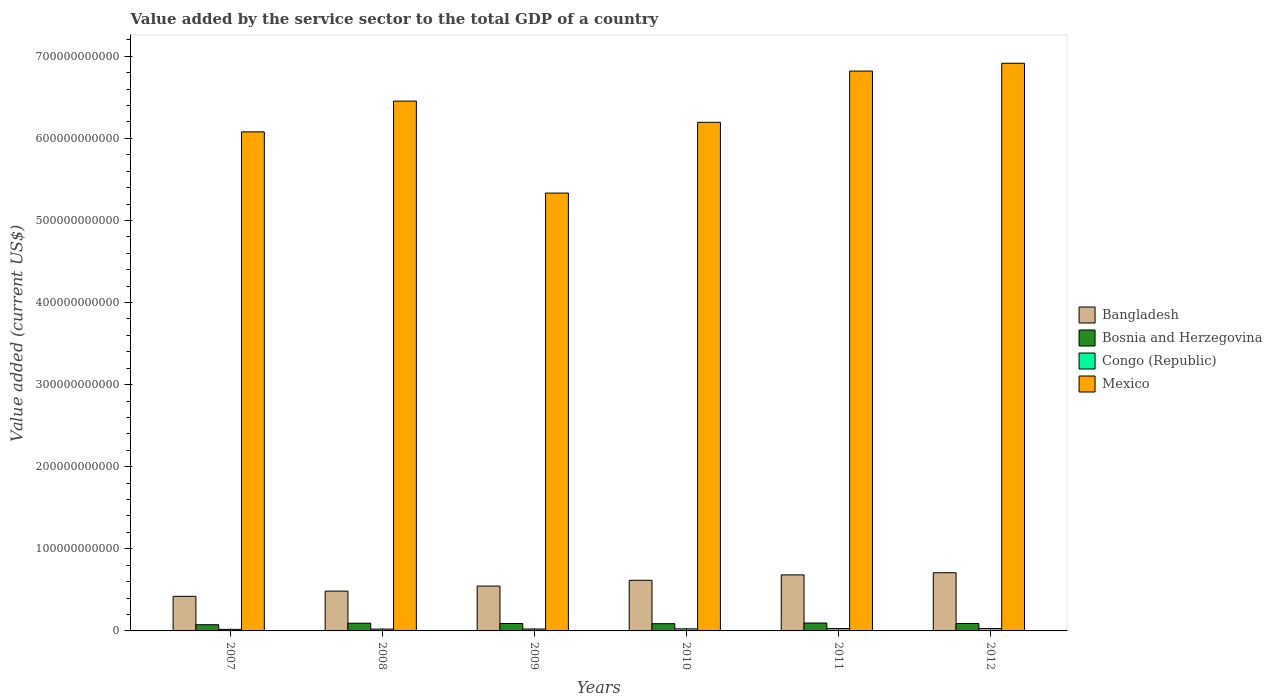How many different coloured bars are there?
Make the answer very short. 4. In how many cases, is the number of bars for a given year not equal to the number of legend labels?
Offer a very short reply. 0. What is the value added by the service sector to the total GDP in Bosnia and Herzegovina in 2012?
Make the answer very short. 9.06e+09. Across all years, what is the maximum value added by the service sector to the total GDP in Bosnia and Herzegovina?
Make the answer very short. 9.64e+09. Across all years, what is the minimum value added by the service sector to the total GDP in Bosnia and Herzegovina?
Give a very brief answer. 7.56e+09. In which year was the value added by the service sector to the total GDP in Bangladesh maximum?
Offer a very short reply. 2012. What is the total value added by the service sector to the total GDP in Bangladesh in the graph?
Your response must be concise. 3.46e+11. What is the difference between the value added by the service sector to the total GDP in Mexico in 2008 and that in 2011?
Keep it short and to the point. -3.66e+1. What is the difference between the value added by the service sector to the total GDP in Bosnia and Herzegovina in 2010 and the value added by the service sector to the total GDP in Mexico in 2009?
Give a very brief answer. -5.25e+11. What is the average value added by the service sector to the total GDP in Congo (Republic) per year?
Your response must be concise. 2.46e+09. In the year 2007, what is the difference between the value added by the service sector to the total GDP in Bosnia and Herzegovina and value added by the service sector to the total GDP in Bangladesh?
Provide a succinct answer. -3.45e+1. In how many years, is the value added by the service sector to the total GDP in Mexico greater than 160000000000 US$?
Offer a very short reply. 6. What is the ratio of the value added by the service sector to the total GDP in Bosnia and Herzegovina in 2010 to that in 2011?
Offer a terse response. 0.91. Is the value added by the service sector to the total GDP in Bangladesh in 2007 less than that in 2010?
Your answer should be very brief. Yes. Is the difference between the value added by the service sector to the total GDP in Bosnia and Herzegovina in 2007 and 2009 greater than the difference between the value added by the service sector to the total GDP in Bangladesh in 2007 and 2009?
Your answer should be compact. Yes. What is the difference between the highest and the second highest value added by the service sector to the total GDP in Bosnia and Herzegovina?
Offer a very short reply. 2.33e+08. What is the difference between the highest and the lowest value added by the service sector to the total GDP in Congo (Republic)?
Your answer should be very brief. 1.03e+09. In how many years, is the value added by the service sector to the total GDP in Bangladesh greater than the average value added by the service sector to the total GDP in Bangladesh taken over all years?
Offer a very short reply. 3. Is the sum of the value added by the service sector to the total GDP in Congo (Republic) in 2011 and 2012 greater than the maximum value added by the service sector to the total GDP in Bosnia and Herzegovina across all years?
Keep it short and to the point. No. What does the 3rd bar from the right in 2012 represents?
Make the answer very short. Bosnia and Herzegovina. Is it the case that in every year, the sum of the value added by the service sector to the total GDP in Congo (Republic) and value added by the service sector to the total GDP in Bangladesh is greater than the value added by the service sector to the total GDP in Bosnia and Herzegovina?
Make the answer very short. Yes. How many bars are there?
Make the answer very short. 24. What is the difference between two consecutive major ticks on the Y-axis?
Your response must be concise. 1.00e+11. Does the graph contain any zero values?
Ensure brevity in your answer.  No. How many legend labels are there?
Offer a terse response. 4. How are the legend labels stacked?
Ensure brevity in your answer.  Vertical. What is the title of the graph?
Your answer should be very brief. Value added by the service sector to the total GDP of a country. What is the label or title of the X-axis?
Offer a very short reply. Years. What is the label or title of the Y-axis?
Ensure brevity in your answer.  Value added (current US$). What is the Value added (current US$) of Bangladesh in 2007?
Offer a very short reply. 4.21e+1. What is the Value added (current US$) in Bosnia and Herzegovina in 2007?
Ensure brevity in your answer.  7.56e+09. What is the Value added (current US$) of Congo (Republic) in 2007?
Provide a succinct answer. 1.88e+09. What is the Value added (current US$) of Mexico in 2007?
Give a very brief answer. 6.08e+11. What is the Value added (current US$) in Bangladesh in 2008?
Give a very brief answer. 4.85e+1. What is the Value added (current US$) in Bosnia and Herzegovina in 2008?
Ensure brevity in your answer.  9.40e+09. What is the Value added (current US$) in Congo (Republic) in 2008?
Provide a succinct answer. 2.24e+09. What is the Value added (current US$) in Mexico in 2008?
Your answer should be compact. 6.45e+11. What is the Value added (current US$) of Bangladesh in 2009?
Offer a very short reply. 5.46e+1. What is the Value added (current US$) of Bosnia and Herzegovina in 2009?
Your answer should be very brief. 9.04e+09. What is the Value added (current US$) in Congo (Republic) in 2009?
Provide a short and direct response. 2.34e+09. What is the Value added (current US$) in Mexico in 2009?
Your answer should be compact. 5.33e+11. What is the Value added (current US$) in Bangladesh in 2010?
Your answer should be compact. 6.17e+1. What is the Value added (current US$) in Bosnia and Herzegovina in 2010?
Make the answer very short. 8.81e+09. What is the Value added (current US$) in Congo (Republic) in 2010?
Offer a very short reply. 2.50e+09. What is the Value added (current US$) of Mexico in 2010?
Your answer should be very brief. 6.20e+11. What is the Value added (current US$) of Bangladesh in 2011?
Offer a very short reply. 6.82e+1. What is the Value added (current US$) of Bosnia and Herzegovina in 2011?
Ensure brevity in your answer.  9.64e+09. What is the Value added (current US$) in Congo (Republic) in 2011?
Keep it short and to the point. 2.88e+09. What is the Value added (current US$) of Mexico in 2011?
Make the answer very short. 6.82e+11. What is the Value added (current US$) in Bangladesh in 2012?
Provide a succinct answer. 7.09e+1. What is the Value added (current US$) of Bosnia and Herzegovina in 2012?
Keep it short and to the point. 9.06e+09. What is the Value added (current US$) of Congo (Republic) in 2012?
Provide a short and direct response. 2.91e+09. What is the Value added (current US$) in Mexico in 2012?
Offer a terse response. 6.91e+11. Across all years, what is the maximum Value added (current US$) of Bangladesh?
Make the answer very short. 7.09e+1. Across all years, what is the maximum Value added (current US$) of Bosnia and Herzegovina?
Give a very brief answer. 9.64e+09. Across all years, what is the maximum Value added (current US$) of Congo (Republic)?
Ensure brevity in your answer.  2.91e+09. Across all years, what is the maximum Value added (current US$) of Mexico?
Your answer should be compact. 6.91e+11. Across all years, what is the minimum Value added (current US$) of Bangladesh?
Provide a short and direct response. 4.21e+1. Across all years, what is the minimum Value added (current US$) in Bosnia and Herzegovina?
Offer a terse response. 7.56e+09. Across all years, what is the minimum Value added (current US$) in Congo (Republic)?
Your response must be concise. 1.88e+09. Across all years, what is the minimum Value added (current US$) of Mexico?
Keep it short and to the point. 5.33e+11. What is the total Value added (current US$) in Bangladesh in the graph?
Your response must be concise. 3.46e+11. What is the total Value added (current US$) in Bosnia and Herzegovina in the graph?
Ensure brevity in your answer.  5.35e+1. What is the total Value added (current US$) of Congo (Republic) in the graph?
Ensure brevity in your answer.  1.48e+1. What is the total Value added (current US$) in Mexico in the graph?
Offer a terse response. 3.78e+12. What is the difference between the Value added (current US$) in Bangladesh in 2007 and that in 2008?
Provide a succinct answer. -6.40e+09. What is the difference between the Value added (current US$) in Bosnia and Herzegovina in 2007 and that in 2008?
Keep it short and to the point. -1.84e+09. What is the difference between the Value added (current US$) of Congo (Republic) in 2007 and that in 2008?
Provide a succinct answer. -3.59e+08. What is the difference between the Value added (current US$) in Mexico in 2007 and that in 2008?
Provide a succinct answer. -3.75e+1. What is the difference between the Value added (current US$) in Bangladesh in 2007 and that in 2009?
Provide a succinct answer. -1.25e+1. What is the difference between the Value added (current US$) of Bosnia and Herzegovina in 2007 and that in 2009?
Your response must be concise. -1.47e+09. What is the difference between the Value added (current US$) in Congo (Republic) in 2007 and that in 2009?
Your response must be concise. -4.56e+08. What is the difference between the Value added (current US$) of Mexico in 2007 and that in 2009?
Provide a short and direct response. 7.45e+1. What is the difference between the Value added (current US$) in Bangladesh in 2007 and that in 2010?
Provide a short and direct response. -1.96e+1. What is the difference between the Value added (current US$) in Bosnia and Herzegovina in 2007 and that in 2010?
Provide a succinct answer. -1.25e+09. What is the difference between the Value added (current US$) in Congo (Republic) in 2007 and that in 2010?
Your answer should be very brief. -6.14e+08. What is the difference between the Value added (current US$) in Mexico in 2007 and that in 2010?
Your response must be concise. -1.16e+1. What is the difference between the Value added (current US$) of Bangladesh in 2007 and that in 2011?
Keep it short and to the point. -2.61e+1. What is the difference between the Value added (current US$) in Bosnia and Herzegovina in 2007 and that in 2011?
Ensure brevity in your answer.  -2.07e+09. What is the difference between the Value added (current US$) of Congo (Republic) in 2007 and that in 2011?
Provide a succinct answer. -1.00e+09. What is the difference between the Value added (current US$) of Mexico in 2007 and that in 2011?
Make the answer very short. -7.41e+1. What is the difference between the Value added (current US$) of Bangladesh in 2007 and that in 2012?
Ensure brevity in your answer.  -2.88e+1. What is the difference between the Value added (current US$) in Bosnia and Herzegovina in 2007 and that in 2012?
Give a very brief answer. -1.49e+09. What is the difference between the Value added (current US$) in Congo (Republic) in 2007 and that in 2012?
Your answer should be compact. -1.03e+09. What is the difference between the Value added (current US$) in Mexico in 2007 and that in 2012?
Provide a succinct answer. -8.36e+1. What is the difference between the Value added (current US$) in Bangladesh in 2008 and that in 2009?
Your response must be concise. -6.14e+09. What is the difference between the Value added (current US$) in Bosnia and Herzegovina in 2008 and that in 2009?
Offer a very short reply. 3.69e+08. What is the difference between the Value added (current US$) in Congo (Republic) in 2008 and that in 2009?
Provide a succinct answer. -9.62e+07. What is the difference between the Value added (current US$) of Mexico in 2008 and that in 2009?
Make the answer very short. 1.12e+11. What is the difference between the Value added (current US$) in Bangladesh in 2008 and that in 2010?
Your answer should be compact. -1.32e+1. What is the difference between the Value added (current US$) in Bosnia and Herzegovina in 2008 and that in 2010?
Make the answer very short. 5.95e+08. What is the difference between the Value added (current US$) in Congo (Republic) in 2008 and that in 2010?
Provide a succinct answer. -2.54e+08. What is the difference between the Value added (current US$) in Mexico in 2008 and that in 2010?
Offer a terse response. 2.59e+1. What is the difference between the Value added (current US$) in Bangladesh in 2008 and that in 2011?
Your response must be concise. -1.97e+1. What is the difference between the Value added (current US$) of Bosnia and Herzegovina in 2008 and that in 2011?
Your response must be concise. -2.33e+08. What is the difference between the Value added (current US$) in Congo (Republic) in 2008 and that in 2011?
Give a very brief answer. -6.41e+08. What is the difference between the Value added (current US$) of Mexico in 2008 and that in 2011?
Make the answer very short. -3.66e+1. What is the difference between the Value added (current US$) in Bangladesh in 2008 and that in 2012?
Offer a terse response. -2.24e+1. What is the difference between the Value added (current US$) in Bosnia and Herzegovina in 2008 and that in 2012?
Your answer should be compact. 3.47e+08. What is the difference between the Value added (current US$) of Congo (Republic) in 2008 and that in 2012?
Ensure brevity in your answer.  -6.72e+08. What is the difference between the Value added (current US$) of Mexico in 2008 and that in 2012?
Your answer should be compact. -4.61e+1. What is the difference between the Value added (current US$) of Bangladesh in 2009 and that in 2010?
Your answer should be compact. -7.03e+09. What is the difference between the Value added (current US$) in Bosnia and Herzegovina in 2009 and that in 2010?
Offer a terse response. 2.26e+08. What is the difference between the Value added (current US$) of Congo (Republic) in 2009 and that in 2010?
Make the answer very short. -1.58e+08. What is the difference between the Value added (current US$) of Mexico in 2009 and that in 2010?
Provide a succinct answer. -8.62e+1. What is the difference between the Value added (current US$) of Bangladesh in 2009 and that in 2011?
Keep it short and to the point. -1.36e+1. What is the difference between the Value added (current US$) of Bosnia and Herzegovina in 2009 and that in 2011?
Give a very brief answer. -6.02e+08. What is the difference between the Value added (current US$) of Congo (Republic) in 2009 and that in 2011?
Provide a succinct answer. -5.45e+08. What is the difference between the Value added (current US$) in Mexico in 2009 and that in 2011?
Make the answer very short. -1.49e+11. What is the difference between the Value added (current US$) in Bangladesh in 2009 and that in 2012?
Provide a succinct answer. -1.62e+1. What is the difference between the Value added (current US$) of Bosnia and Herzegovina in 2009 and that in 2012?
Provide a succinct answer. -2.16e+07. What is the difference between the Value added (current US$) of Congo (Republic) in 2009 and that in 2012?
Provide a succinct answer. -5.76e+08. What is the difference between the Value added (current US$) in Mexico in 2009 and that in 2012?
Make the answer very short. -1.58e+11. What is the difference between the Value added (current US$) in Bangladesh in 2010 and that in 2011?
Provide a short and direct response. -6.56e+09. What is the difference between the Value added (current US$) of Bosnia and Herzegovina in 2010 and that in 2011?
Your answer should be compact. -8.27e+08. What is the difference between the Value added (current US$) in Congo (Republic) in 2010 and that in 2011?
Ensure brevity in your answer.  -3.87e+08. What is the difference between the Value added (current US$) in Mexico in 2010 and that in 2011?
Your response must be concise. -6.24e+1. What is the difference between the Value added (current US$) of Bangladesh in 2010 and that in 2012?
Provide a short and direct response. -9.21e+09. What is the difference between the Value added (current US$) in Bosnia and Herzegovina in 2010 and that in 2012?
Keep it short and to the point. -2.48e+08. What is the difference between the Value added (current US$) of Congo (Republic) in 2010 and that in 2012?
Ensure brevity in your answer.  -4.18e+08. What is the difference between the Value added (current US$) of Mexico in 2010 and that in 2012?
Offer a terse response. -7.19e+1. What is the difference between the Value added (current US$) of Bangladesh in 2011 and that in 2012?
Offer a very short reply. -2.64e+09. What is the difference between the Value added (current US$) in Bosnia and Herzegovina in 2011 and that in 2012?
Give a very brief answer. 5.80e+08. What is the difference between the Value added (current US$) of Congo (Republic) in 2011 and that in 2012?
Your response must be concise. -3.04e+07. What is the difference between the Value added (current US$) in Mexico in 2011 and that in 2012?
Keep it short and to the point. -9.51e+09. What is the difference between the Value added (current US$) of Bangladesh in 2007 and the Value added (current US$) of Bosnia and Herzegovina in 2008?
Your response must be concise. 3.27e+1. What is the difference between the Value added (current US$) of Bangladesh in 2007 and the Value added (current US$) of Congo (Republic) in 2008?
Offer a terse response. 3.99e+1. What is the difference between the Value added (current US$) in Bangladesh in 2007 and the Value added (current US$) in Mexico in 2008?
Make the answer very short. -6.03e+11. What is the difference between the Value added (current US$) of Bosnia and Herzegovina in 2007 and the Value added (current US$) of Congo (Republic) in 2008?
Ensure brevity in your answer.  5.32e+09. What is the difference between the Value added (current US$) in Bosnia and Herzegovina in 2007 and the Value added (current US$) in Mexico in 2008?
Provide a short and direct response. -6.38e+11. What is the difference between the Value added (current US$) of Congo (Republic) in 2007 and the Value added (current US$) of Mexico in 2008?
Provide a succinct answer. -6.44e+11. What is the difference between the Value added (current US$) of Bangladesh in 2007 and the Value added (current US$) of Bosnia and Herzegovina in 2009?
Provide a short and direct response. 3.31e+1. What is the difference between the Value added (current US$) of Bangladesh in 2007 and the Value added (current US$) of Congo (Republic) in 2009?
Your answer should be compact. 3.98e+1. What is the difference between the Value added (current US$) in Bangladesh in 2007 and the Value added (current US$) in Mexico in 2009?
Give a very brief answer. -4.91e+11. What is the difference between the Value added (current US$) of Bosnia and Herzegovina in 2007 and the Value added (current US$) of Congo (Republic) in 2009?
Offer a very short reply. 5.22e+09. What is the difference between the Value added (current US$) of Bosnia and Herzegovina in 2007 and the Value added (current US$) of Mexico in 2009?
Make the answer very short. -5.26e+11. What is the difference between the Value added (current US$) of Congo (Republic) in 2007 and the Value added (current US$) of Mexico in 2009?
Provide a short and direct response. -5.31e+11. What is the difference between the Value added (current US$) in Bangladesh in 2007 and the Value added (current US$) in Bosnia and Herzegovina in 2010?
Ensure brevity in your answer.  3.33e+1. What is the difference between the Value added (current US$) in Bangladesh in 2007 and the Value added (current US$) in Congo (Republic) in 2010?
Provide a short and direct response. 3.96e+1. What is the difference between the Value added (current US$) in Bangladesh in 2007 and the Value added (current US$) in Mexico in 2010?
Your response must be concise. -5.77e+11. What is the difference between the Value added (current US$) of Bosnia and Herzegovina in 2007 and the Value added (current US$) of Congo (Republic) in 2010?
Your answer should be very brief. 5.07e+09. What is the difference between the Value added (current US$) of Bosnia and Herzegovina in 2007 and the Value added (current US$) of Mexico in 2010?
Your answer should be compact. -6.12e+11. What is the difference between the Value added (current US$) of Congo (Republic) in 2007 and the Value added (current US$) of Mexico in 2010?
Make the answer very short. -6.18e+11. What is the difference between the Value added (current US$) of Bangladesh in 2007 and the Value added (current US$) of Bosnia and Herzegovina in 2011?
Your answer should be very brief. 3.25e+1. What is the difference between the Value added (current US$) of Bangladesh in 2007 and the Value added (current US$) of Congo (Republic) in 2011?
Your response must be concise. 3.92e+1. What is the difference between the Value added (current US$) in Bangladesh in 2007 and the Value added (current US$) in Mexico in 2011?
Keep it short and to the point. -6.40e+11. What is the difference between the Value added (current US$) in Bosnia and Herzegovina in 2007 and the Value added (current US$) in Congo (Republic) in 2011?
Provide a succinct answer. 4.68e+09. What is the difference between the Value added (current US$) of Bosnia and Herzegovina in 2007 and the Value added (current US$) of Mexico in 2011?
Give a very brief answer. -6.74e+11. What is the difference between the Value added (current US$) of Congo (Republic) in 2007 and the Value added (current US$) of Mexico in 2011?
Your answer should be very brief. -6.80e+11. What is the difference between the Value added (current US$) in Bangladesh in 2007 and the Value added (current US$) in Bosnia and Herzegovina in 2012?
Ensure brevity in your answer.  3.30e+1. What is the difference between the Value added (current US$) in Bangladesh in 2007 and the Value added (current US$) in Congo (Republic) in 2012?
Your answer should be compact. 3.92e+1. What is the difference between the Value added (current US$) of Bangladesh in 2007 and the Value added (current US$) of Mexico in 2012?
Offer a terse response. -6.49e+11. What is the difference between the Value added (current US$) of Bosnia and Herzegovina in 2007 and the Value added (current US$) of Congo (Republic) in 2012?
Your answer should be compact. 4.65e+09. What is the difference between the Value added (current US$) in Bosnia and Herzegovina in 2007 and the Value added (current US$) in Mexico in 2012?
Ensure brevity in your answer.  -6.84e+11. What is the difference between the Value added (current US$) in Congo (Republic) in 2007 and the Value added (current US$) in Mexico in 2012?
Your response must be concise. -6.90e+11. What is the difference between the Value added (current US$) in Bangladesh in 2008 and the Value added (current US$) in Bosnia and Herzegovina in 2009?
Keep it short and to the point. 3.95e+1. What is the difference between the Value added (current US$) in Bangladesh in 2008 and the Value added (current US$) in Congo (Republic) in 2009?
Your response must be concise. 4.62e+1. What is the difference between the Value added (current US$) in Bangladesh in 2008 and the Value added (current US$) in Mexico in 2009?
Your response must be concise. -4.85e+11. What is the difference between the Value added (current US$) in Bosnia and Herzegovina in 2008 and the Value added (current US$) in Congo (Republic) in 2009?
Ensure brevity in your answer.  7.07e+09. What is the difference between the Value added (current US$) of Bosnia and Herzegovina in 2008 and the Value added (current US$) of Mexico in 2009?
Offer a very short reply. -5.24e+11. What is the difference between the Value added (current US$) in Congo (Republic) in 2008 and the Value added (current US$) in Mexico in 2009?
Offer a terse response. -5.31e+11. What is the difference between the Value added (current US$) of Bangladesh in 2008 and the Value added (current US$) of Bosnia and Herzegovina in 2010?
Provide a short and direct response. 3.97e+1. What is the difference between the Value added (current US$) of Bangladesh in 2008 and the Value added (current US$) of Congo (Republic) in 2010?
Ensure brevity in your answer.  4.60e+1. What is the difference between the Value added (current US$) of Bangladesh in 2008 and the Value added (current US$) of Mexico in 2010?
Ensure brevity in your answer.  -5.71e+11. What is the difference between the Value added (current US$) in Bosnia and Herzegovina in 2008 and the Value added (current US$) in Congo (Republic) in 2010?
Ensure brevity in your answer.  6.91e+09. What is the difference between the Value added (current US$) in Bosnia and Herzegovina in 2008 and the Value added (current US$) in Mexico in 2010?
Your answer should be compact. -6.10e+11. What is the difference between the Value added (current US$) of Congo (Republic) in 2008 and the Value added (current US$) of Mexico in 2010?
Keep it short and to the point. -6.17e+11. What is the difference between the Value added (current US$) of Bangladesh in 2008 and the Value added (current US$) of Bosnia and Herzegovina in 2011?
Your response must be concise. 3.89e+1. What is the difference between the Value added (current US$) in Bangladesh in 2008 and the Value added (current US$) in Congo (Republic) in 2011?
Offer a terse response. 4.56e+1. What is the difference between the Value added (current US$) in Bangladesh in 2008 and the Value added (current US$) in Mexico in 2011?
Keep it short and to the point. -6.33e+11. What is the difference between the Value added (current US$) in Bosnia and Herzegovina in 2008 and the Value added (current US$) in Congo (Republic) in 2011?
Your answer should be very brief. 6.52e+09. What is the difference between the Value added (current US$) of Bosnia and Herzegovina in 2008 and the Value added (current US$) of Mexico in 2011?
Offer a terse response. -6.73e+11. What is the difference between the Value added (current US$) of Congo (Republic) in 2008 and the Value added (current US$) of Mexico in 2011?
Your answer should be very brief. -6.80e+11. What is the difference between the Value added (current US$) in Bangladesh in 2008 and the Value added (current US$) in Bosnia and Herzegovina in 2012?
Offer a terse response. 3.94e+1. What is the difference between the Value added (current US$) in Bangladesh in 2008 and the Value added (current US$) in Congo (Republic) in 2012?
Your answer should be very brief. 4.56e+1. What is the difference between the Value added (current US$) in Bangladesh in 2008 and the Value added (current US$) in Mexico in 2012?
Offer a very short reply. -6.43e+11. What is the difference between the Value added (current US$) of Bosnia and Herzegovina in 2008 and the Value added (current US$) of Congo (Republic) in 2012?
Your answer should be very brief. 6.49e+09. What is the difference between the Value added (current US$) in Bosnia and Herzegovina in 2008 and the Value added (current US$) in Mexico in 2012?
Offer a terse response. -6.82e+11. What is the difference between the Value added (current US$) of Congo (Republic) in 2008 and the Value added (current US$) of Mexico in 2012?
Offer a very short reply. -6.89e+11. What is the difference between the Value added (current US$) in Bangladesh in 2009 and the Value added (current US$) in Bosnia and Herzegovina in 2010?
Provide a succinct answer. 4.58e+1. What is the difference between the Value added (current US$) in Bangladesh in 2009 and the Value added (current US$) in Congo (Republic) in 2010?
Make the answer very short. 5.21e+1. What is the difference between the Value added (current US$) in Bangladesh in 2009 and the Value added (current US$) in Mexico in 2010?
Your response must be concise. -5.65e+11. What is the difference between the Value added (current US$) in Bosnia and Herzegovina in 2009 and the Value added (current US$) in Congo (Republic) in 2010?
Give a very brief answer. 6.54e+09. What is the difference between the Value added (current US$) in Bosnia and Herzegovina in 2009 and the Value added (current US$) in Mexico in 2010?
Provide a short and direct response. -6.10e+11. What is the difference between the Value added (current US$) in Congo (Republic) in 2009 and the Value added (current US$) in Mexico in 2010?
Your response must be concise. -6.17e+11. What is the difference between the Value added (current US$) in Bangladesh in 2009 and the Value added (current US$) in Bosnia and Herzegovina in 2011?
Your answer should be compact. 4.50e+1. What is the difference between the Value added (current US$) in Bangladesh in 2009 and the Value added (current US$) in Congo (Republic) in 2011?
Keep it short and to the point. 5.18e+1. What is the difference between the Value added (current US$) of Bangladesh in 2009 and the Value added (current US$) of Mexico in 2011?
Ensure brevity in your answer.  -6.27e+11. What is the difference between the Value added (current US$) of Bosnia and Herzegovina in 2009 and the Value added (current US$) of Congo (Republic) in 2011?
Keep it short and to the point. 6.15e+09. What is the difference between the Value added (current US$) in Bosnia and Herzegovina in 2009 and the Value added (current US$) in Mexico in 2011?
Keep it short and to the point. -6.73e+11. What is the difference between the Value added (current US$) of Congo (Republic) in 2009 and the Value added (current US$) of Mexico in 2011?
Ensure brevity in your answer.  -6.80e+11. What is the difference between the Value added (current US$) in Bangladesh in 2009 and the Value added (current US$) in Bosnia and Herzegovina in 2012?
Your answer should be very brief. 4.56e+1. What is the difference between the Value added (current US$) in Bangladesh in 2009 and the Value added (current US$) in Congo (Republic) in 2012?
Your answer should be very brief. 5.17e+1. What is the difference between the Value added (current US$) of Bangladesh in 2009 and the Value added (current US$) of Mexico in 2012?
Keep it short and to the point. -6.37e+11. What is the difference between the Value added (current US$) of Bosnia and Herzegovina in 2009 and the Value added (current US$) of Congo (Republic) in 2012?
Make the answer very short. 6.12e+09. What is the difference between the Value added (current US$) in Bosnia and Herzegovina in 2009 and the Value added (current US$) in Mexico in 2012?
Ensure brevity in your answer.  -6.82e+11. What is the difference between the Value added (current US$) of Congo (Republic) in 2009 and the Value added (current US$) of Mexico in 2012?
Give a very brief answer. -6.89e+11. What is the difference between the Value added (current US$) in Bangladesh in 2010 and the Value added (current US$) in Bosnia and Herzegovina in 2011?
Offer a terse response. 5.20e+1. What is the difference between the Value added (current US$) in Bangladesh in 2010 and the Value added (current US$) in Congo (Republic) in 2011?
Give a very brief answer. 5.88e+1. What is the difference between the Value added (current US$) of Bangladesh in 2010 and the Value added (current US$) of Mexico in 2011?
Give a very brief answer. -6.20e+11. What is the difference between the Value added (current US$) of Bosnia and Herzegovina in 2010 and the Value added (current US$) of Congo (Republic) in 2011?
Your response must be concise. 5.93e+09. What is the difference between the Value added (current US$) in Bosnia and Herzegovina in 2010 and the Value added (current US$) in Mexico in 2011?
Give a very brief answer. -6.73e+11. What is the difference between the Value added (current US$) of Congo (Republic) in 2010 and the Value added (current US$) of Mexico in 2011?
Ensure brevity in your answer.  -6.79e+11. What is the difference between the Value added (current US$) in Bangladesh in 2010 and the Value added (current US$) in Bosnia and Herzegovina in 2012?
Keep it short and to the point. 5.26e+1. What is the difference between the Value added (current US$) of Bangladesh in 2010 and the Value added (current US$) of Congo (Republic) in 2012?
Offer a terse response. 5.88e+1. What is the difference between the Value added (current US$) of Bangladesh in 2010 and the Value added (current US$) of Mexico in 2012?
Offer a terse response. -6.30e+11. What is the difference between the Value added (current US$) in Bosnia and Herzegovina in 2010 and the Value added (current US$) in Congo (Republic) in 2012?
Your answer should be very brief. 5.89e+09. What is the difference between the Value added (current US$) of Bosnia and Herzegovina in 2010 and the Value added (current US$) of Mexico in 2012?
Your answer should be very brief. -6.83e+11. What is the difference between the Value added (current US$) of Congo (Republic) in 2010 and the Value added (current US$) of Mexico in 2012?
Keep it short and to the point. -6.89e+11. What is the difference between the Value added (current US$) in Bangladesh in 2011 and the Value added (current US$) in Bosnia and Herzegovina in 2012?
Keep it short and to the point. 5.92e+1. What is the difference between the Value added (current US$) of Bangladesh in 2011 and the Value added (current US$) of Congo (Republic) in 2012?
Make the answer very short. 6.53e+1. What is the difference between the Value added (current US$) of Bangladesh in 2011 and the Value added (current US$) of Mexico in 2012?
Ensure brevity in your answer.  -6.23e+11. What is the difference between the Value added (current US$) of Bosnia and Herzegovina in 2011 and the Value added (current US$) of Congo (Republic) in 2012?
Ensure brevity in your answer.  6.72e+09. What is the difference between the Value added (current US$) in Bosnia and Herzegovina in 2011 and the Value added (current US$) in Mexico in 2012?
Offer a very short reply. -6.82e+11. What is the difference between the Value added (current US$) of Congo (Republic) in 2011 and the Value added (current US$) of Mexico in 2012?
Offer a terse response. -6.89e+11. What is the average Value added (current US$) in Bangladesh per year?
Your response must be concise. 5.77e+1. What is the average Value added (current US$) of Bosnia and Herzegovina per year?
Your answer should be very brief. 8.92e+09. What is the average Value added (current US$) of Congo (Republic) per year?
Ensure brevity in your answer.  2.46e+09. What is the average Value added (current US$) in Mexico per year?
Provide a short and direct response. 6.30e+11. In the year 2007, what is the difference between the Value added (current US$) of Bangladesh and Value added (current US$) of Bosnia and Herzegovina?
Offer a very short reply. 3.45e+1. In the year 2007, what is the difference between the Value added (current US$) in Bangladesh and Value added (current US$) in Congo (Republic)?
Give a very brief answer. 4.02e+1. In the year 2007, what is the difference between the Value added (current US$) of Bangladesh and Value added (current US$) of Mexico?
Provide a short and direct response. -5.66e+11. In the year 2007, what is the difference between the Value added (current US$) of Bosnia and Herzegovina and Value added (current US$) of Congo (Republic)?
Keep it short and to the point. 5.68e+09. In the year 2007, what is the difference between the Value added (current US$) of Bosnia and Herzegovina and Value added (current US$) of Mexico?
Offer a terse response. -6.00e+11. In the year 2007, what is the difference between the Value added (current US$) in Congo (Republic) and Value added (current US$) in Mexico?
Make the answer very short. -6.06e+11. In the year 2008, what is the difference between the Value added (current US$) of Bangladesh and Value added (current US$) of Bosnia and Herzegovina?
Make the answer very short. 3.91e+1. In the year 2008, what is the difference between the Value added (current US$) of Bangladesh and Value added (current US$) of Congo (Republic)?
Your answer should be very brief. 4.63e+1. In the year 2008, what is the difference between the Value added (current US$) in Bangladesh and Value added (current US$) in Mexico?
Offer a very short reply. -5.97e+11. In the year 2008, what is the difference between the Value added (current US$) in Bosnia and Herzegovina and Value added (current US$) in Congo (Republic)?
Give a very brief answer. 7.16e+09. In the year 2008, what is the difference between the Value added (current US$) of Bosnia and Herzegovina and Value added (current US$) of Mexico?
Your response must be concise. -6.36e+11. In the year 2008, what is the difference between the Value added (current US$) of Congo (Republic) and Value added (current US$) of Mexico?
Make the answer very short. -6.43e+11. In the year 2009, what is the difference between the Value added (current US$) of Bangladesh and Value added (current US$) of Bosnia and Herzegovina?
Provide a short and direct response. 4.56e+1. In the year 2009, what is the difference between the Value added (current US$) in Bangladesh and Value added (current US$) in Congo (Republic)?
Keep it short and to the point. 5.23e+1. In the year 2009, what is the difference between the Value added (current US$) in Bangladesh and Value added (current US$) in Mexico?
Offer a very short reply. -4.79e+11. In the year 2009, what is the difference between the Value added (current US$) in Bosnia and Herzegovina and Value added (current US$) in Congo (Republic)?
Give a very brief answer. 6.70e+09. In the year 2009, what is the difference between the Value added (current US$) of Bosnia and Herzegovina and Value added (current US$) of Mexico?
Offer a very short reply. -5.24e+11. In the year 2009, what is the difference between the Value added (current US$) in Congo (Republic) and Value added (current US$) in Mexico?
Provide a short and direct response. -5.31e+11. In the year 2010, what is the difference between the Value added (current US$) in Bangladesh and Value added (current US$) in Bosnia and Herzegovina?
Your response must be concise. 5.29e+1. In the year 2010, what is the difference between the Value added (current US$) of Bangladesh and Value added (current US$) of Congo (Republic)?
Offer a terse response. 5.92e+1. In the year 2010, what is the difference between the Value added (current US$) in Bangladesh and Value added (current US$) in Mexico?
Provide a succinct answer. -5.58e+11. In the year 2010, what is the difference between the Value added (current US$) in Bosnia and Herzegovina and Value added (current US$) in Congo (Republic)?
Provide a short and direct response. 6.31e+09. In the year 2010, what is the difference between the Value added (current US$) of Bosnia and Herzegovina and Value added (current US$) of Mexico?
Give a very brief answer. -6.11e+11. In the year 2010, what is the difference between the Value added (current US$) in Congo (Republic) and Value added (current US$) in Mexico?
Give a very brief answer. -6.17e+11. In the year 2011, what is the difference between the Value added (current US$) in Bangladesh and Value added (current US$) in Bosnia and Herzegovina?
Your answer should be very brief. 5.86e+1. In the year 2011, what is the difference between the Value added (current US$) in Bangladesh and Value added (current US$) in Congo (Republic)?
Your response must be concise. 6.54e+1. In the year 2011, what is the difference between the Value added (current US$) in Bangladesh and Value added (current US$) in Mexico?
Offer a terse response. -6.14e+11. In the year 2011, what is the difference between the Value added (current US$) in Bosnia and Herzegovina and Value added (current US$) in Congo (Republic)?
Make the answer very short. 6.75e+09. In the year 2011, what is the difference between the Value added (current US$) in Bosnia and Herzegovina and Value added (current US$) in Mexico?
Ensure brevity in your answer.  -6.72e+11. In the year 2011, what is the difference between the Value added (current US$) of Congo (Republic) and Value added (current US$) of Mexico?
Provide a succinct answer. -6.79e+11. In the year 2012, what is the difference between the Value added (current US$) of Bangladesh and Value added (current US$) of Bosnia and Herzegovina?
Provide a succinct answer. 6.18e+1. In the year 2012, what is the difference between the Value added (current US$) in Bangladesh and Value added (current US$) in Congo (Republic)?
Offer a terse response. 6.80e+1. In the year 2012, what is the difference between the Value added (current US$) in Bangladesh and Value added (current US$) in Mexico?
Offer a terse response. -6.21e+11. In the year 2012, what is the difference between the Value added (current US$) in Bosnia and Herzegovina and Value added (current US$) in Congo (Republic)?
Offer a terse response. 6.14e+09. In the year 2012, what is the difference between the Value added (current US$) in Bosnia and Herzegovina and Value added (current US$) in Mexico?
Give a very brief answer. -6.82e+11. In the year 2012, what is the difference between the Value added (current US$) in Congo (Republic) and Value added (current US$) in Mexico?
Provide a short and direct response. -6.89e+11. What is the ratio of the Value added (current US$) in Bangladesh in 2007 to that in 2008?
Offer a very short reply. 0.87. What is the ratio of the Value added (current US$) of Bosnia and Herzegovina in 2007 to that in 2008?
Offer a terse response. 0.8. What is the ratio of the Value added (current US$) in Congo (Republic) in 2007 to that in 2008?
Your answer should be very brief. 0.84. What is the ratio of the Value added (current US$) in Mexico in 2007 to that in 2008?
Your answer should be very brief. 0.94. What is the ratio of the Value added (current US$) of Bangladesh in 2007 to that in 2009?
Make the answer very short. 0.77. What is the ratio of the Value added (current US$) in Bosnia and Herzegovina in 2007 to that in 2009?
Provide a succinct answer. 0.84. What is the ratio of the Value added (current US$) of Congo (Republic) in 2007 to that in 2009?
Give a very brief answer. 0.81. What is the ratio of the Value added (current US$) of Mexico in 2007 to that in 2009?
Give a very brief answer. 1.14. What is the ratio of the Value added (current US$) of Bangladesh in 2007 to that in 2010?
Your response must be concise. 0.68. What is the ratio of the Value added (current US$) in Bosnia and Herzegovina in 2007 to that in 2010?
Offer a very short reply. 0.86. What is the ratio of the Value added (current US$) of Congo (Republic) in 2007 to that in 2010?
Give a very brief answer. 0.75. What is the ratio of the Value added (current US$) of Mexico in 2007 to that in 2010?
Your answer should be very brief. 0.98. What is the ratio of the Value added (current US$) of Bangladesh in 2007 to that in 2011?
Offer a very short reply. 0.62. What is the ratio of the Value added (current US$) of Bosnia and Herzegovina in 2007 to that in 2011?
Give a very brief answer. 0.78. What is the ratio of the Value added (current US$) of Congo (Republic) in 2007 to that in 2011?
Give a very brief answer. 0.65. What is the ratio of the Value added (current US$) of Mexico in 2007 to that in 2011?
Provide a short and direct response. 0.89. What is the ratio of the Value added (current US$) in Bangladesh in 2007 to that in 2012?
Provide a succinct answer. 0.59. What is the ratio of the Value added (current US$) in Bosnia and Herzegovina in 2007 to that in 2012?
Keep it short and to the point. 0.83. What is the ratio of the Value added (current US$) of Congo (Republic) in 2007 to that in 2012?
Your answer should be compact. 0.65. What is the ratio of the Value added (current US$) in Mexico in 2007 to that in 2012?
Keep it short and to the point. 0.88. What is the ratio of the Value added (current US$) in Bangladesh in 2008 to that in 2009?
Your answer should be compact. 0.89. What is the ratio of the Value added (current US$) of Bosnia and Herzegovina in 2008 to that in 2009?
Provide a short and direct response. 1.04. What is the ratio of the Value added (current US$) in Congo (Republic) in 2008 to that in 2009?
Keep it short and to the point. 0.96. What is the ratio of the Value added (current US$) in Mexico in 2008 to that in 2009?
Keep it short and to the point. 1.21. What is the ratio of the Value added (current US$) of Bangladesh in 2008 to that in 2010?
Offer a terse response. 0.79. What is the ratio of the Value added (current US$) of Bosnia and Herzegovina in 2008 to that in 2010?
Give a very brief answer. 1.07. What is the ratio of the Value added (current US$) in Congo (Republic) in 2008 to that in 2010?
Offer a terse response. 0.9. What is the ratio of the Value added (current US$) in Mexico in 2008 to that in 2010?
Offer a terse response. 1.04. What is the ratio of the Value added (current US$) of Bangladesh in 2008 to that in 2011?
Ensure brevity in your answer.  0.71. What is the ratio of the Value added (current US$) of Bosnia and Herzegovina in 2008 to that in 2011?
Ensure brevity in your answer.  0.98. What is the ratio of the Value added (current US$) in Congo (Republic) in 2008 to that in 2011?
Provide a succinct answer. 0.78. What is the ratio of the Value added (current US$) in Mexico in 2008 to that in 2011?
Your answer should be compact. 0.95. What is the ratio of the Value added (current US$) in Bangladesh in 2008 to that in 2012?
Your answer should be compact. 0.68. What is the ratio of the Value added (current US$) of Bosnia and Herzegovina in 2008 to that in 2012?
Your answer should be very brief. 1.04. What is the ratio of the Value added (current US$) in Congo (Republic) in 2008 to that in 2012?
Your response must be concise. 0.77. What is the ratio of the Value added (current US$) in Mexico in 2008 to that in 2012?
Give a very brief answer. 0.93. What is the ratio of the Value added (current US$) in Bangladesh in 2009 to that in 2010?
Provide a succinct answer. 0.89. What is the ratio of the Value added (current US$) of Bosnia and Herzegovina in 2009 to that in 2010?
Make the answer very short. 1.03. What is the ratio of the Value added (current US$) of Congo (Republic) in 2009 to that in 2010?
Keep it short and to the point. 0.94. What is the ratio of the Value added (current US$) of Mexico in 2009 to that in 2010?
Your answer should be very brief. 0.86. What is the ratio of the Value added (current US$) in Bangladesh in 2009 to that in 2011?
Make the answer very short. 0.8. What is the ratio of the Value added (current US$) of Bosnia and Herzegovina in 2009 to that in 2011?
Make the answer very short. 0.94. What is the ratio of the Value added (current US$) of Congo (Republic) in 2009 to that in 2011?
Your response must be concise. 0.81. What is the ratio of the Value added (current US$) of Mexico in 2009 to that in 2011?
Your response must be concise. 0.78. What is the ratio of the Value added (current US$) of Bangladesh in 2009 to that in 2012?
Your answer should be compact. 0.77. What is the ratio of the Value added (current US$) of Bosnia and Herzegovina in 2009 to that in 2012?
Offer a terse response. 1. What is the ratio of the Value added (current US$) in Congo (Republic) in 2009 to that in 2012?
Provide a short and direct response. 0.8. What is the ratio of the Value added (current US$) of Mexico in 2009 to that in 2012?
Offer a very short reply. 0.77. What is the ratio of the Value added (current US$) of Bangladesh in 2010 to that in 2011?
Offer a terse response. 0.9. What is the ratio of the Value added (current US$) in Bosnia and Herzegovina in 2010 to that in 2011?
Make the answer very short. 0.91. What is the ratio of the Value added (current US$) of Congo (Republic) in 2010 to that in 2011?
Offer a very short reply. 0.87. What is the ratio of the Value added (current US$) of Mexico in 2010 to that in 2011?
Ensure brevity in your answer.  0.91. What is the ratio of the Value added (current US$) in Bangladesh in 2010 to that in 2012?
Make the answer very short. 0.87. What is the ratio of the Value added (current US$) of Bosnia and Herzegovina in 2010 to that in 2012?
Ensure brevity in your answer.  0.97. What is the ratio of the Value added (current US$) of Congo (Republic) in 2010 to that in 2012?
Provide a short and direct response. 0.86. What is the ratio of the Value added (current US$) of Mexico in 2010 to that in 2012?
Give a very brief answer. 0.9. What is the ratio of the Value added (current US$) in Bangladesh in 2011 to that in 2012?
Make the answer very short. 0.96. What is the ratio of the Value added (current US$) of Bosnia and Herzegovina in 2011 to that in 2012?
Ensure brevity in your answer.  1.06. What is the ratio of the Value added (current US$) in Congo (Republic) in 2011 to that in 2012?
Provide a succinct answer. 0.99. What is the ratio of the Value added (current US$) in Mexico in 2011 to that in 2012?
Keep it short and to the point. 0.99. What is the difference between the highest and the second highest Value added (current US$) in Bangladesh?
Give a very brief answer. 2.64e+09. What is the difference between the highest and the second highest Value added (current US$) of Bosnia and Herzegovina?
Your answer should be very brief. 2.33e+08. What is the difference between the highest and the second highest Value added (current US$) of Congo (Republic)?
Provide a short and direct response. 3.04e+07. What is the difference between the highest and the second highest Value added (current US$) of Mexico?
Offer a terse response. 9.51e+09. What is the difference between the highest and the lowest Value added (current US$) in Bangladesh?
Provide a succinct answer. 2.88e+1. What is the difference between the highest and the lowest Value added (current US$) in Bosnia and Herzegovina?
Ensure brevity in your answer.  2.07e+09. What is the difference between the highest and the lowest Value added (current US$) in Congo (Republic)?
Your response must be concise. 1.03e+09. What is the difference between the highest and the lowest Value added (current US$) of Mexico?
Make the answer very short. 1.58e+11. 